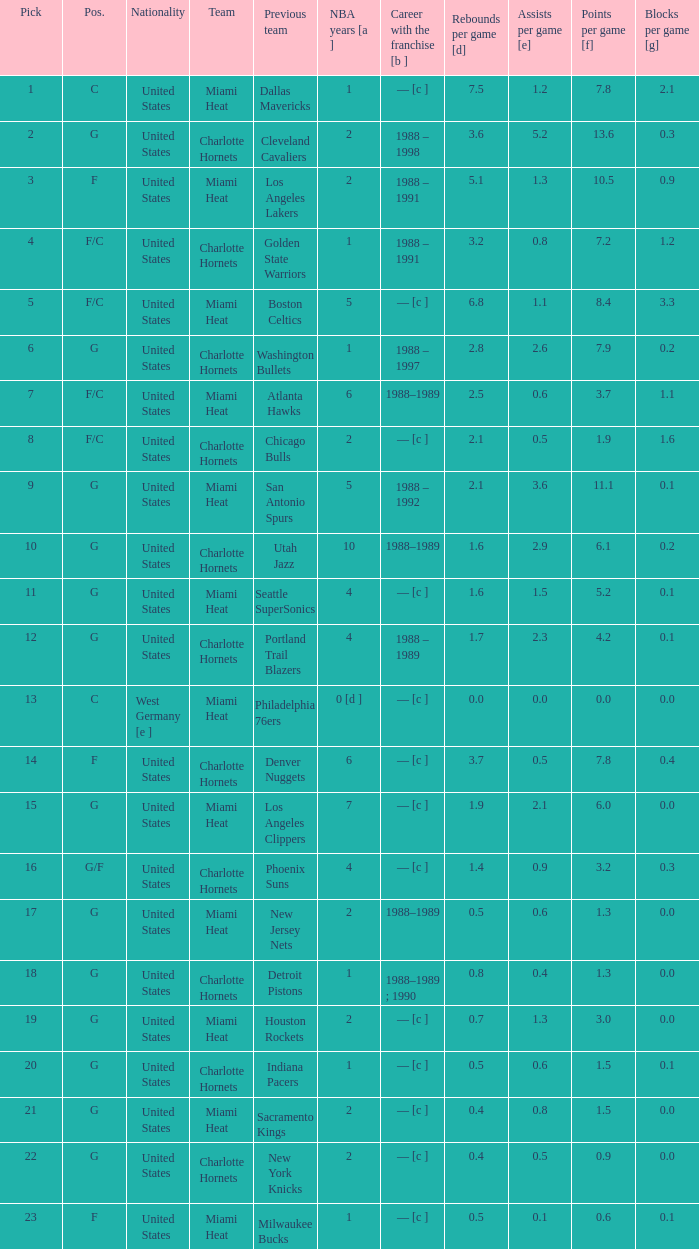What is the previous team of the player with 4 NBA years and a pick less than 16? Seattle SuperSonics, Portland Trail Blazers. 